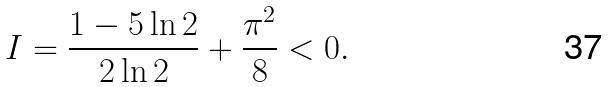Convert formula to latex. <formula><loc_0><loc_0><loc_500><loc_500>I = \frac { 1 - 5 \ln 2 } { 2 \ln 2 } + \frac { \pi ^ { 2 } } { 8 } < 0 .</formula> 